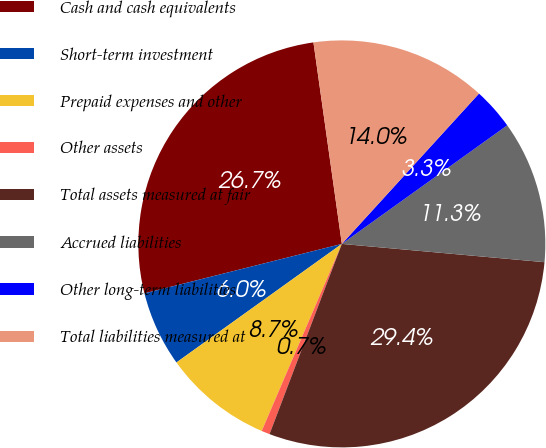Convert chart. <chart><loc_0><loc_0><loc_500><loc_500><pie_chart><fcel>Cash and cash equivalents<fcel>Short-term investment<fcel>Prepaid expenses and other<fcel>Other assets<fcel>Total assets measured at fair<fcel>Accrued liabilities<fcel>Other long-term liabilities<fcel>Total liabilities measured at<nl><fcel>26.68%<fcel>5.99%<fcel>8.66%<fcel>0.66%<fcel>29.35%<fcel>11.33%<fcel>3.33%<fcel>14.0%<nl></chart> 